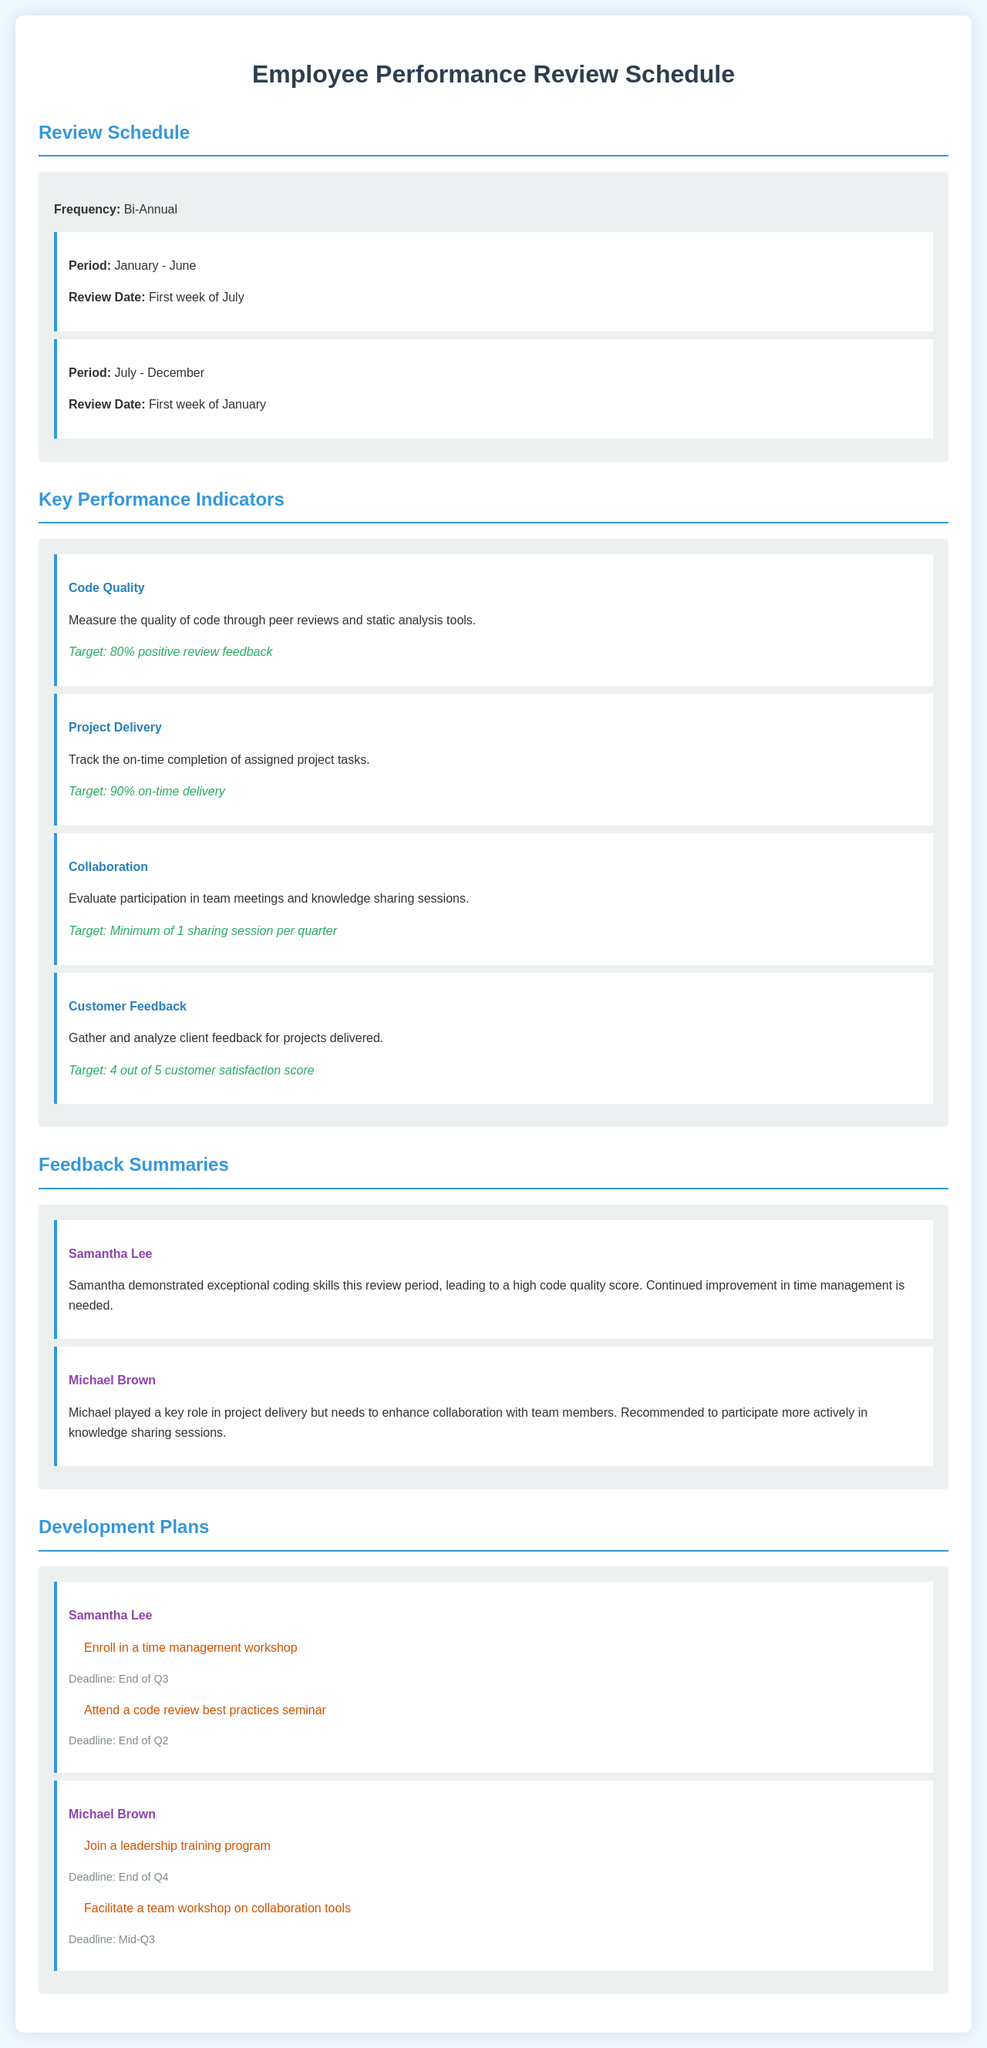what is the frequency of reviews? The document states that the review frequency is bi-annual.
Answer: Bi-Annual when is the review date for the period January - June? The review date for this period is the first week of July.
Answer: First week of July what is the target for code quality? The document specifies that the target for code quality is 80% positive review feedback.
Answer: 80% positive review feedback who needs to enroll in a time management workshop? The document mentions that Samantha Lee needs to enroll in this workshop.
Answer: Samantha Lee what is the target for customer feedback? The document states that the target for customer feedback is a 4 out of 5 customer satisfaction score.
Answer: 4 out of 5 who should facilitate a team workshop on collaboration tools? According to the document, Michael Brown should facilitate this workshop.
Answer: Michael Brown how many knowledge sharing sessions should an employee participate in per quarter? The document indicates that the minimum participation is one sharing session per quarter.
Answer: Minimum of 1 sharing session per quarter what is the deadline for Michael Brown to join a leadership training program? The document states that the deadline is the end of Q4.
Answer: End of Q4 